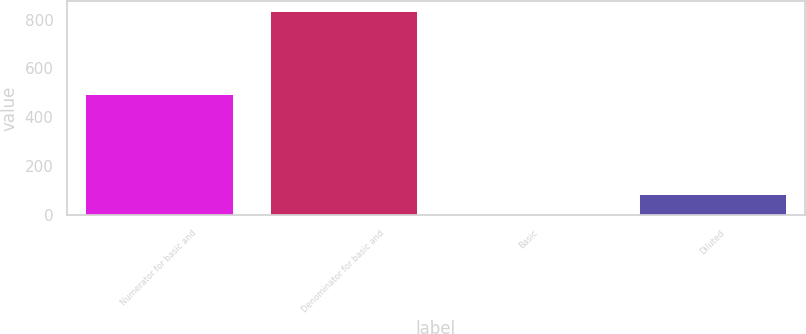<chart> <loc_0><loc_0><loc_500><loc_500><bar_chart><fcel>Numerator for basic and<fcel>Denominator for basic and<fcel>Basic<fcel>Diluted<nl><fcel>497<fcel>835<fcel>0.6<fcel>84.04<nl></chart> 